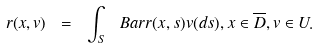Convert formula to latex. <formula><loc_0><loc_0><loc_500><loc_500>r ( x , v ) \ = \ \int _ { S } \ B a r { r } ( x , s ) v ( d s ) , x \in \overline { D } , v \in U .</formula> 